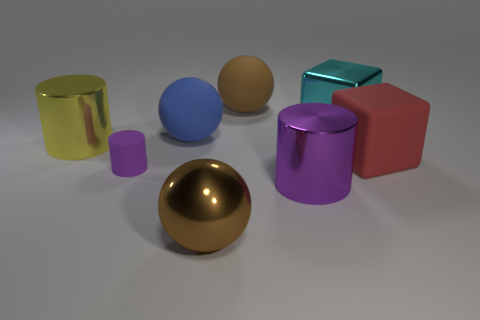Subtract all large cylinders. How many cylinders are left? 1 Subtract all brown spheres. How many spheres are left? 1 Add 2 big cyan metal blocks. How many objects exist? 10 Subtract all cubes. How many objects are left? 6 Subtract 2 blocks. How many blocks are left? 0 Subtract all blue spheres. Subtract all blue cubes. How many spheres are left? 2 Subtract all purple cylinders. How many yellow balls are left? 0 Subtract all tiny objects. Subtract all purple rubber cylinders. How many objects are left? 6 Add 6 matte cylinders. How many matte cylinders are left? 7 Add 1 yellow shiny cylinders. How many yellow shiny cylinders exist? 2 